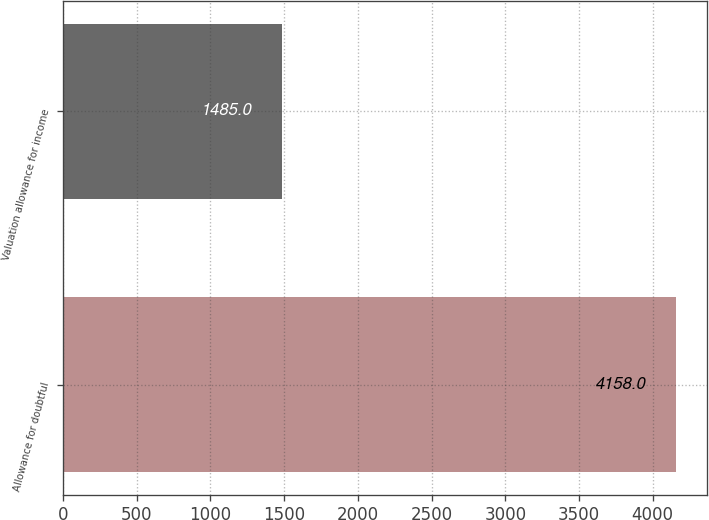<chart> <loc_0><loc_0><loc_500><loc_500><bar_chart><fcel>Allowance for doubtful<fcel>Valuation allowance for income<nl><fcel>4158<fcel>1485<nl></chart> 